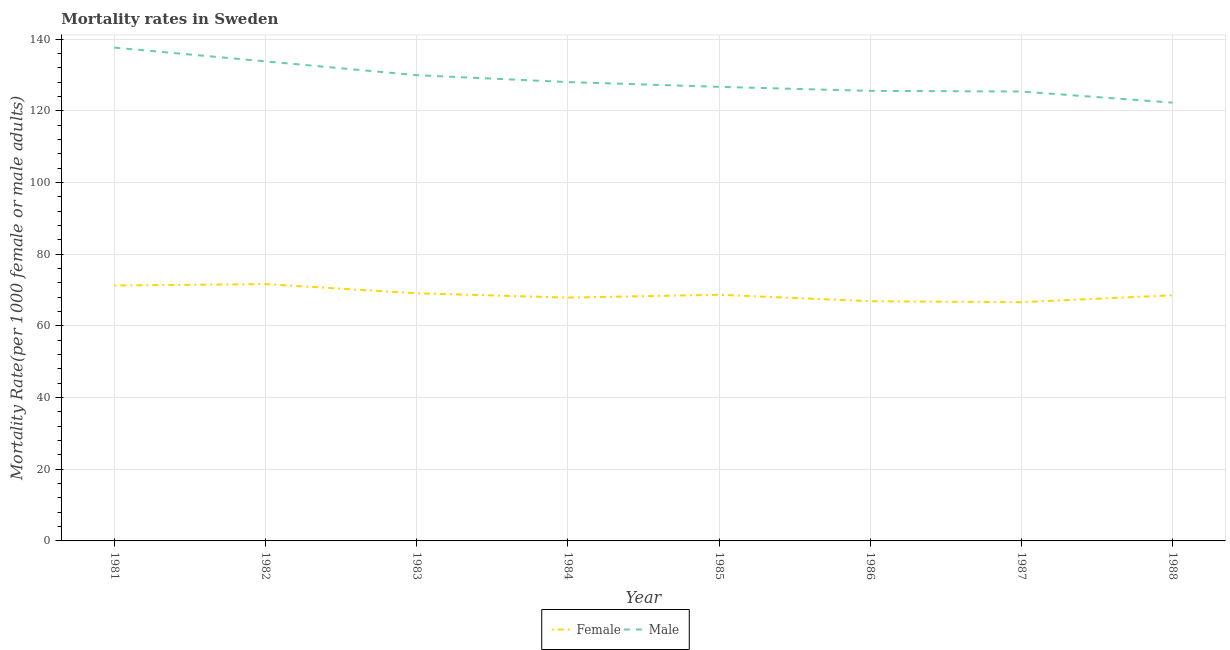How many different coloured lines are there?
Offer a very short reply. 2. Is the number of lines equal to the number of legend labels?
Keep it short and to the point. Yes. What is the male mortality rate in 1988?
Provide a succinct answer. 122.28. Across all years, what is the maximum male mortality rate?
Your response must be concise. 137.64. Across all years, what is the minimum male mortality rate?
Offer a very short reply. 122.28. In which year was the female mortality rate minimum?
Give a very brief answer. 1987. What is the total female mortality rate in the graph?
Keep it short and to the point. 550.64. What is the difference between the female mortality rate in 1983 and that in 1986?
Ensure brevity in your answer.  2.2. What is the difference between the male mortality rate in 1986 and the female mortality rate in 1981?
Keep it short and to the point. 54.3. What is the average male mortality rate per year?
Provide a short and direct response. 128.67. In the year 1983, what is the difference between the male mortality rate and female mortality rate?
Provide a short and direct response. 60.86. What is the ratio of the female mortality rate in 1982 to that in 1984?
Provide a succinct answer. 1.06. What is the difference between the highest and the second highest male mortality rate?
Provide a succinct answer. 3.84. What is the difference between the highest and the lowest female mortality rate?
Ensure brevity in your answer.  5.05. Is the male mortality rate strictly less than the female mortality rate over the years?
Your answer should be compact. No. How many years are there in the graph?
Provide a succinct answer. 8. Are the values on the major ticks of Y-axis written in scientific E-notation?
Your response must be concise. No. Does the graph contain grids?
Provide a short and direct response. Yes. What is the title of the graph?
Ensure brevity in your answer.  Mortality rates in Sweden. Does "Girls" appear as one of the legend labels in the graph?
Your answer should be compact. No. What is the label or title of the Y-axis?
Offer a very short reply. Mortality Rate(per 1000 female or male adults). What is the Mortality Rate(per 1000 female or male adults) of Female in 1981?
Provide a succinct answer. 71.27. What is the Mortality Rate(per 1000 female or male adults) in Male in 1981?
Your answer should be very brief. 137.64. What is the Mortality Rate(per 1000 female or male adults) of Female in 1982?
Your response must be concise. 71.66. What is the Mortality Rate(per 1000 female or male adults) of Male in 1982?
Provide a succinct answer. 133.8. What is the Mortality Rate(per 1000 female or male adults) in Female in 1983?
Ensure brevity in your answer.  69.09. What is the Mortality Rate(per 1000 female or male adults) of Male in 1983?
Provide a succinct answer. 129.95. What is the Mortality Rate(per 1000 female or male adults) of Female in 1984?
Keep it short and to the point. 67.89. What is the Mortality Rate(per 1000 female or male adults) of Male in 1984?
Your answer should be very brief. 128.03. What is the Mortality Rate(per 1000 female or male adults) of Female in 1985?
Give a very brief answer. 68.68. What is the Mortality Rate(per 1000 female or male adults) of Male in 1985?
Provide a short and direct response. 126.69. What is the Mortality Rate(per 1000 female or male adults) of Female in 1986?
Give a very brief answer. 66.89. What is the Mortality Rate(per 1000 female or male adults) of Male in 1986?
Ensure brevity in your answer.  125.57. What is the Mortality Rate(per 1000 female or male adults) in Female in 1987?
Your response must be concise. 66.61. What is the Mortality Rate(per 1000 female or male adults) in Male in 1987?
Your answer should be very brief. 125.39. What is the Mortality Rate(per 1000 female or male adults) in Female in 1988?
Your answer should be very brief. 68.56. What is the Mortality Rate(per 1000 female or male adults) of Male in 1988?
Keep it short and to the point. 122.28. Across all years, what is the maximum Mortality Rate(per 1000 female or male adults) in Female?
Provide a succinct answer. 71.66. Across all years, what is the maximum Mortality Rate(per 1000 female or male adults) of Male?
Ensure brevity in your answer.  137.64. Across all years, what is the minimum Mortality Rate(per 1000 female or male adults) of Female?
Ensure brevity in your answer.  66.61. Across all years, what is the minimum Mortality Rate(per 1000 female or male adults) in Male?
Offer a very short reply. 122.28. What is the total Mortality Rate(per 1000 female or male adults) in Female in the graph?
Ensure brevity in your answer.  550.64. What is the total Mortality Rate(per 1000 female or male adults) in Male in the graph?
Your answer should be compact. 1029.36. What is the difference between the Mortality Rate(per 1000 female or male adults) of Female in 1981 and that in 1982?
Your response must be concise. -0.39. What is the difference between the Mortality Rate(per 1000 female or male adults) of Male in 1981 and that in 1982?
Your answer should be very brief. 3.84. What is the difference between the Mortality Rate(per 1000 female or male adults) in Female in 1981 and that in 1983?
Ensure brevity in your answer.  2.18. What is the difference between the Mortality Rate(per 1000 female or male adults) in Male in 1981 and that in 1983?
Keep it short and to the point. 7.7. What is the difference between the Mortality Rate(per 1000 female or male adults) of Female in 1981 and that in 1984?
Provide a succinct answer. 3.38. What is the difference between the Mortality Rate(per 1000 female or male adults) in Male in 1981 and that in 1984?
Offer a terse response. 9.61. What is the difference between the Mortality Rate(per 1000 female or male adults) in Female in 1981 and that in 1985?
Your answer should be very brief. 2.6. What is the difference between the Mortality Rate(per 1000 female or male adults) in Male in 1981 and that in 1985?
Your answer should be compact. 10.95. What is the difference between the Mortality Rate(per 1000 female or male adults) in Female in 1981 and that in 1986?
Ensure brevity in your answer.  4.38. What is the difference between the Mortality Rate(per 1000 female or male adults) in Male in 1981 and that in 1986?
Give a very brief answer. 12.07. What is the difference between the Mortality Rate(per 1000 female or male adults) in Female in 1981 and that in 1987?
Your answer should be compact. 4.66. What is the difference between the Mortality Rate(per 1000 female or male adults) of Male in 1981 and that in 1987?
Offer a very short reply. 12.25. What is the difference between the Mortality Rate(per 1000 female or male adults) in Female in 1981 and that in 1988?
Your answer should be compact. 2.72. What is the difference between the Mortality Rate(per 1000 female or male adults) in Male in 1981 and that in 1988?
Make the answer very short. 15.36. What is the difference between the Mortality Rate(per 1000 female or male adults) of Female in 1982 and that in 1983?
Your answer should be compact. 2.56. What is the difference between the Mortality Rate(per 1000 female or male adults) in Male in 1982 and that in 1983?
Provide a short and direct response. 3.85. What is the difference between the Mortality Rate(per 1000 female or male adults) in Female in 1982 and that in 1984?
Your answer should be compact. 3.76. What is the difference between the Mortality Rate(per 1000 female or male adults) in Male in 1982 and that in 1984?
Keep it short and to the point. 5.77. What is the difference between the Mortality Rate(per 1000 female or male adults) in Female in 1982 and that in 1985?
Your response must be concise. 2.98. What is the difference between the Mortality Rate(per 1000 female or male adults) in Male in 1982 and that in 1985?
Your answer should be very brief. 7.11. What is the difference between the Mortality Rate(per 1000 female or male adults) in Female in 1982 and that in 1986?
Give a very brief answer. 4.77. What is the difference between the Mortality Rate(per 1000 female or male adults) of Male in 1982 and that in 1986?
Ensure brevity in your answer.  8.23. What is the difference between the Mortality Rate(per 1000 female or male adults) in Female in 1982 and that in 1987?
Provide a short and direct response. 5.05. What is the difference between the Mortality Rate(per 1000 female or male adults) of Male in 1982 and that in 1987?
Offer a terse response. 8.41. What is the difference between the Mortality Rate(per 1000 female or male adults) of Female in 1982 and that in 1988?
Offer a very short reply. 3.1. What is the difference between the Mortality Rate(per 1000 female or male adults) in Male in 1982 and that in 1988?
Your response must be concise. 11.52. What is the difference between the Mortality Rate(per 1000 female or male adults) in Female in 1983 and that in 1984?
Give a very brief answer. 1.2. What is the difference between the Mortality Rate(per 1000 female or male adults) in Male in 1983 and that in 1984?
Give a very brief answer. 1.92. What is the difference between the Mortality Rate(per 1000 female or male adults) in Female in 1983 and that in 1985?
Your response must be concise. 0.42. What is the difference between the Mortality Rate(per 1000 female or male adults) in Male in 1983 and that in 1985?
Provide a short and direct response. 3.25. What is the difference between the Mortality Rate(per 1000 female or male adults) of Female in 1983 and that in 1986?
Give a very brief answer. 2.21. What is the difference between the Mortality Rate(per 1000 female or male adults) in Male in 1983 and that in 1986?
Offer a very short reply. 4.38. What is the difference between the Mortality Rate(per 1000 female or male adults) of Female in 1983 and that in 1987?
Offer a terse response. 2.48. What is the difference between the Mortality Rate(per 1000 female or male adults) of Male in 1983 and that in 1987?
Make the answer very short. 4.56. What is the difference between the Mortality Rate(per 1000 female or male adults) in Female in 1983 and that in 1988?
Offer a very short reply. 0.54. What is the difference between the Mortality Rate(per 1000 female or male adults) of Male in 1983 and that in 1988?
Your answer should be compact. 7.67. What is the difference between the Mortality Rate(per 1000 female or male adults) of Female in 1984 and that in 1985?
Provide a succinct answer. -0.78. What is the difference between the Mortality Rate(per 1000 female or male adults) in Male in 1984 and that in 1985?
Keep it short and to the point. 1.33. What is the difference between the Mortality Rate(per 1000 female or male adults) in Female in 1984 and that in 1986?
Keep it short and to the point. 1.01. What is the difference between the Mortality Rate(per 1000 female or male adults) of Male in 1984 and that in 1986?
Provide a succinct answer. 2.46. What is the difference between the Mortality Rate(per 1000 female or male adults) in Female in 1984 and that in 1987?
Provide a short and direct response. 1.29. What is the difference between the Mortality Rate(per 1000 female or male adults) in Male in 1984 and that in 1987?
Your answer should be compact. 2.64. What is the difference between the Mortality Rate(per 1000 female or male adults) in Female in 1984 and that in 1988?
Make the answer very short. -0.66. What is the difference between the Mortality Rate(per 1000 female or male adults) of Male in 1984 and that in 1988?
Your answer should be very brief. 5.75. What is the difference between the Mortality Rate(per 1000 female or male adults) in Female in 1985 and that in 1986?
Ensure brevity in your answer.  1.79. What is the difference between the Mortality Rate(per 1000 female or male adults) of Female in 1985 and that in 1987?
Ensure brevity in your answer.  2.07. What is the difference between the Mortality Rate(per 1000 female or male adults) of Male in 1985 and that in 1987?
Your answer should be compact. 1.3. What is the difference between the Mortality Rate(per 1000 female or male adults) of Female in 1985 and that in 1988?
Ensure brevity in your answer.  0.12. What is the difference between the Mortality Rate(per 1000 female or male adults) of Male in 1985 and that in 1988?
Give a very brief answer. 4.42. What is the difference between the Mortality Rate(per 1000 female or male adults) of Female in 1986 and that in 1987?
Make the answer very short. 0.28. What is the difference between the Mortality Rate(per 1000 female or male adults) of Male in 1986 and that in 1987?
Give a very brief answer. 0.18. What is the difference between the Mortality Rate(per 1000 female or male adults) of Female in 1986 and that in 1988?
Give a very brief answer. -1.67. What is the difference between the Mortality Rate(per 1000 female or male adults) in Male in 1986 and that in 1988?
Make the answer very short. 3.29. What is the difference between the Mortality Rate(per 1000 female or male adults) in Female in 1987 and that in 1988?
Offer a very short reply. -1.95. What is the difference between the Mortality Rate(per 1000 female or male adults) in Male in 1987 and that in 1988?
Offer a terse response. 3.11. What is the difference between the Mortality Rate(per 1000 female or male adults) in Female in 1981 and the Mortality Rate(per 1000 female or male adults) in Male in 1982?
Offer a terse response. -62.53. What is the difference between the Mortality Rate(per 1000 female or male adults) in Female in 1981 and the Mortality Rate(per 1000 female or male adults) in Male in 1983?
Provide a short and direct response. -58.68. What is the difference between the Mortality Rate(per 1000 female or male adults) of Female in 1981 and the Mortality Rate(per 1000 female or male adults) of Male in 1984?
Keep it short and to the point. -56.76. What is the difference between the Mortality Rate(per 1000 female or male adults) of Female in 1981 and the Mortality Rate(per 1000 female or male adults) of Male in 1985?
Keep it short and to the point. -55.42. What is the difference between the Mortality Rate(per 1000 female or male adults) in Female in 1981 and the Mortality Rate(per 1000 female or male adults) in Male in 1986?
Offer a very short reply. -54.3. What is the difference between the Mortality Rate(per 1000 female or male adults) in Female in 1981 and the Mortality Rate(per 1000 female or male adults) in Male in 1987?
Keep it short and to the point. -54.12. What is the difference between the Mortality Rate(per 1000 female or male adults) in Female in 1981 and the Mortality Rate(per 1000 female or male adults) in Male in 1988?
Give a very brief answer. -51.01. What is the difference between the Mortality Rate(per 1000 female or male adults) in Female in 1982 and the Mortality Rate(per 1000 female or male adults) in Male in 1983?
Make the answer very short. -58.29. What is the difference between the Mortality Rate(per 1000 female or male adults) of Female in 1982 and the Mortality Rate(per 1000 female or male adults) of Male in 1984?
Your answer should be compact. -56.37. What is the difference between the Mortality Rate(per 1000 female or male adults) in Female in 1982 and the Mortality Rate(per 1000 female or male adults) in Male in 1985?
Your answer should be very brief. -55.04. What is the difference between the Mortality Rate(per 1000 female or male adults) in Female in 1982 and the Mortality Rate(per 1000 female or male adults) in Male in 1986?
Provide a succinct answer. -53.91. What is the difference between the Mortality Rate(per 1000 female or male adults) of Female in 1982 and the Mortality Rate(per 1000 female or male adults) of Male in 1987?
Your answer should be compact. -53.73. What is the difference between the Mortality Rate(per 1000 female or male adults) of Female in 1982 and the Mortality Rate(per 1000 female or male adults) of Male in 1988?
Offer a terse response. -50.62. What is the difference between the Mortality Rate(per 1000 female or male adults) in Female in 1983 and the Mortality Rate(per 1000 female or male adults) in Male in 1984?
Offer a very short reply. -58.94. What is the difference between the Mortality Rate(per 1000 female or male adults) in Female in 1983 and the Mortality Rate(per 1000 female or male adults) in Male in 1985?
Provide a short and direct response. -57.6. What is the difference between the Mortality Rate(per 1000 female or male adults) in Female in 1983 and the Mortality Rate(per 1000 female or male adults) in Male in 1986?
Offer a terse response. -56.48. What is the difference between the Mortality Rate(per 1000 female or male adults) in Female in 1983 and the Mortality Rate(per 1000 female or male adults) in Male in 1987?
Offer a terse response. -56.3. What is the difference between the Mortality Rate(per 1000 female or male adults) in Female in 1983 and the Mortality Rate(per 1000 female or male adults) in Male in 1988?
Your response must be concise. -53.19. What is the difference between the Mortality Rate(per 1000 female or male adults) in Female in 1984 and the Mortality Rate(per 1000 female or male adults) in Male in 1985?
Your answer should be compact. -58.8. What is the difference between the Mortality Rate(per 1000 female or male adults) of Female in 1984 and the Mortality Rate(per 1000 female or male adults) of Male in 1986?
Offer a very short reply. -57.68. What is the difference between the Mortality Rate(per 1000 female or male adults) of Female in 1984 and the Mortality Rate(per 1000 female or male adults) of Male in 1987?
Provide a short and direct response. -57.5. What is the difference between the Mortality Rate(per 1000 female or male adults) of Female in 1984 and the Mortality Rate(per 1000 female or male adults) of Male in 1988?
Provide a succinct answer. -54.39. What is the difference between the Mortality Rate(per 1000 female or male adults) of Female in 1985 and the Mortality Rate(per 1000 female or male adults) of Male in 1986?
Make the answer very short. -56.89. What is the difference between the Mortality Rate(per 1000 female or male adults) of Female in 1985 and the Mortality Rate(per 1000 female or male adults) of Male in 1987?
Give a very brief answer. -56.72. What is the difference between the Mortality Rate(per 1000 female or male adults) of Female in 1985 and the Mortality Rate(per 1000 female or male adults) of Male in 1988?
Your response must be concise. -53.6. What is the difference between the Mortality Rate(per 1000 female or male adults) in Female in 1986 and the Mortality Rate(per 1000 female or male adults) in Male in 1987?
Make the answer very short. -58.5. What is the difference between the Mortality Rate(per 1000 female or male adults) of Female in 1986 and the Mortality Rate(per 1000 female or male adults) of Male in 1988?
Your answer should be compact. -55.39. What is the difference between the Mortality Rate(per 1000 female or male adults) of Female in 1987 and the Mortality Rate(per 1000 female or male adults) of Male in 1988?
Your answer should be compact. -55.67. What is the average Mortality Rate(per 1000 female or male adults) in Female per year?
Provide a succinct answer. 68.83. What is the average Mortality Rate(per 1000 female or male adults) in Male per year?
Provide a succinct answer. 128.67. In the year 1981, what is the difference between the Mortality Rate(per 1000 female or male adults) of Female and Mortality Rate(per 1000 female or male adults) of Male?
Provide a succinct answer. -66.37. In the year 1982, what is the difference between the Mortality Rate(per 1000 female or male adults) in Female and Mortality Rate(per 1000 female or male adults) in Male?
Keep it short and to the point. -62.15. In the year 1983, what is the difference between the Mortality Rate(per 1000 female or male adults) in Female and Mortality Rate(per 1000 female or male adults) in Male?
Make the answer very short. -60.86. In the year 1984, what is the difference between the Mortality Rate(per 1000 female or male adults) in Female and Mortality Rate(per 1000 female or male adults) in Male?
Offer a terse response. -60.13. In the year 1985, what is the difference between the Mortality Rate(per 1000 female or male adults) in Female and Mortality Rate(per 1000 female or male adults) in Male?
Keep it short and to the point. -58.02. In the year 1986, what is the difference between the Mortality Rate(per 1000 female or male adults) in Female and Mortality Rate(per 1000 female or male adults) in Male?
Your answer should be compact. -58.68. In the year 1987, what is the difference between the Mortality Rate(per 1000 female or male adults) in Female and Mortality Rate(per 1000 female or male adults) in Male?
Keep it short and to the point. -58.78. In the year 1988, what is the difference between the Mortality Rate(per 1000 female or male adults) in Female and Mortality Rate(per 1000 female or male adults) in Male?
Your answer should be very brief. -53.73. What is the ratio of the Mortality Rate(per 1000 female or male adults) of Male in 1981 to that in 1982?
Provide a short and direct response. 1.03. What is the ratio of the Mortality Rate(per 1000 female or male adults) in Female in 1981 to that in 1983?
Ensure brevity in your answer.  1.03. What is the ratio of the Mortality Rate(per 1000 female or male adults) in Male in 1981 to that in 1983?
Provide a short and direct response. 1.06. What is the ratio of the Mortality Rate(per 1000 female or male adults) in Female in 1981 to that in 1984?
Keep it short and to the point. 1.05. What is the ratio of the Mortality Rate(per 1000 female or male adults) in Male in 1981 to that in 1984?
Your answer should be very brief. 1.08. What is the ratio of the Mortality Rate(per 1000 female or male adults) of Female in 1981 to that in 1985?
Provide a succinct answer. 1.04. What is the ratio of the Mortality Rate(per 1000 female or male adults) in Male in 1981 to that in 1985?
Offer a very short reply. 1.09. What is the ratio of the Mortality Rate(per 1000 female or male adults) of Female in 1981 to that in 1986?
Provide a short and direct response. 1.07. What is the ratio of the Mortality Rate(per 1000 female or male adults) of Male in 1981 to that in 1986?
Your answer should be compact. 1.1. What is the ratio of the Mortality Rate(per 1000 female or male adults) in Female in 1981 to that in 1987?
Keep it short and to the point. 1.07. What is the ratio of the Mortality Rate(per 1000 female or male adults) in Male in 1981 to that in 1987?
Provide a succinct answer. 1.1. What is the ratio of the Mortality Rate(per 1000 female or male adults) of Female in 1981 to that in 1988?
Your response must be concise. 1.04. What is the ratio of the Mortality Rate(per 1000 female or male adults) in Male in 1981 to that in 1988?
Offer a terse response. 1.13. What is the ratio of the Mortality Rate(per 1000 female or male adults) in Female in 1982 to that in 1983?
Offer a very short reply. 1.04. What is the ratio of the Mortality Rate(per 1000 female or male adults) of Male in 1982 to that in 1983?
Make the answer very short. 1.03. What is the ratio of the Mortality Rate(per 1000 female or male adults) in Female in 1982 to that in 1984?
Your response must be concise. 1.06. What is the ratio of the Mortality Rate(per 1000 female or male adults) of Male in 1982 to that in 1984?
Ensure brevity in your answer.  1.05. What is the ratio of the Mortality Rate(per 1000 female or male adults) of Female in 1982 to that in 1985?
Your answer should be compact. 1.04. What is the ratio of the Mortality Rate(per 1000 female or male adults) of Male in 1982 to that in 1985?
Give a very brief answer. 1.06. What is the ratio of the Mortality Rate(per 1000 female or male adults) in Female in 1982 to that in 1986?
Your response must be concise. 1.07. What is the ratio of the Mortality Rate(per 1000 female or male adults) of Male in 1982 to that in 1986?
Provide a succinct answer. 1.07. What is the ratio of the Mortality Rate(per 1000 female or male adults) of Female in 1982 to that in 1987?
Offer a terse response. 1.08. What is the ratio of the Mortality Rate(per 1000 female or male adults) of Male in 1982 to that in 1987?
Make the answer very short. 1.07. What is the ratio of the Mortality Rate(per 1000 female or male adults) in Female in 1982 to that in 1988?
Make the answer very short. 1.05. What is the ratio of the Mortality Rate(per 1000 female or male adults) of Male in 1982 to that in 1988?
Make the answer very short. 1.09. What is the ratio of the Mortality Rate(per 1000 female or male adults) in Female in 1983 to that in 1984?
Ensure brevity in your answer.  1.02. What is the ratio of the Mortality Rate(per 1000 female or male adults) in Male in 1983 to that in 1985?
Make the answer very short. 1.03. What is the ratio of the Mortality Rate(per 1000 female or male adults) in Female in 1983 to that in 1986?
Offer a very short reply. 1.03. What is the ratio of the Mortality Rate(per 1000 female or male adults) of Male in 1983 to that in 1986?
Ensure brevity in your answer.  1.03. What is the ratio of the Mortality Rate(per 1000 female or male adults) of Female in 1983 to that in 1987?
Provide a short and direct response. 1.04. What is the ratio of the Mortality Rate(per 1000 female or male adults) in Male in 1983 to that in 1987?
Make the answer very short. 1.04. What is the ratio of the Mortality Rate(per 1000 female or male adults) in Male in 1983 to that in 1988?
Give a very brief answer. 1.06. What is the ratio of the Mortality Rate(per 1000 female or male adults) in Male in 1984 to that in 1985?
Keep it short and to the point. 1.01. What is the ratio of the Mortality Rate(per 1000 female or male adults) in Female in 1984 to that in 1986?
Provide a short and direct response. 1.02. What is the ratio of the Mortality Rate(per 1000 female or male adults) in Male in 1984 to that in 1986?
Your answer should be very brief. 1.02. What is the ratio of the Mortality Rate(per 1000 female or male adults) of Female in 1984 to that in 1987?
Make the answer very short. 1.02. What is the ratio of the Mortality Rate(per 1000 female or male adults) in Male in 1984 to that in 1987?
Provide a short and direct response. 1.02. What is the ratio of the Mortality Rate(per 1000 female or male adults) of Female in 1984 to that in 1988?
Provide a succinct answer. 0.99. What is the ratio of the Mortality Rate(per 1000 female or male adults) of Male in 1984 to that in 1988?
Provide a succinct answer. 1.05. What is the ratio of the Mortality Rate(per 1000 female or male adults) in Female in 1985 to that in 1986?
Offer a terse response. 1.03. What is the ratio of the Mortality Rate(per 1000 female or male adults) of Male in 1985 to that in 1986?
Ensure brevity in your answer.  1.01. What is the ratio of the Mortality Rate(per 1000 female or male adults) in Female in 1985 to that in 1987?
Give a very brief answer. 1.03. What is the ratio of the Mortality Rate(per 1000 female or male adults) in Male in 1985 to that in 1987?
Your response must be concise. 1.01. What is the ratio of the Mortality Rate(per 1000 female or male adults) in Male in 1985 to that in 1988?
Provide a short and direct response. 1.04. What is the ratio of the Mortality Rate(per 1000 female or male adults) in Male in 1986 to that in 1987?
Your response must be concise. 1. What is the ratio of the Mortality Rate(per 1000 female or male adults) of Female in 1986 to that in 1988?
Provide a short and direct response. 0.98. What is the ratio of the Mortality Rate(per 1000 female or male adults) of Male in 1986 to that in 1988?
Offer a terse response. 1.03. What is the ratio of the Mortality Rate(per 1000 female or male adults) in Female in 1987 to that in 1988?
Offer a very short reply. 0.97. What is the ratio of the Mortality Rate(per 1000 female or male adults) in Male in 1987 to that in 1988?
Make the answer very short. 1.03. What is the difference between the highest and the second highest Mortality Rate(per 1000 female or male adults) of Female?
Make the answer very short. 0.39. What is the difference between the highest and the second highest Mortality Rate(per 1000 female or male adults) of Male?
Keep it short and to the point. 3.84. What is the difference between the highest and the lowest Mortality Rate(per 1000 female or male adults) of Female?
Your response must be concise. 5.05. What is the difference between the highest and the lowest Mortality Rate(per 1000 female or male adults) of Male?
Provide a succinct answer. 15.36. 